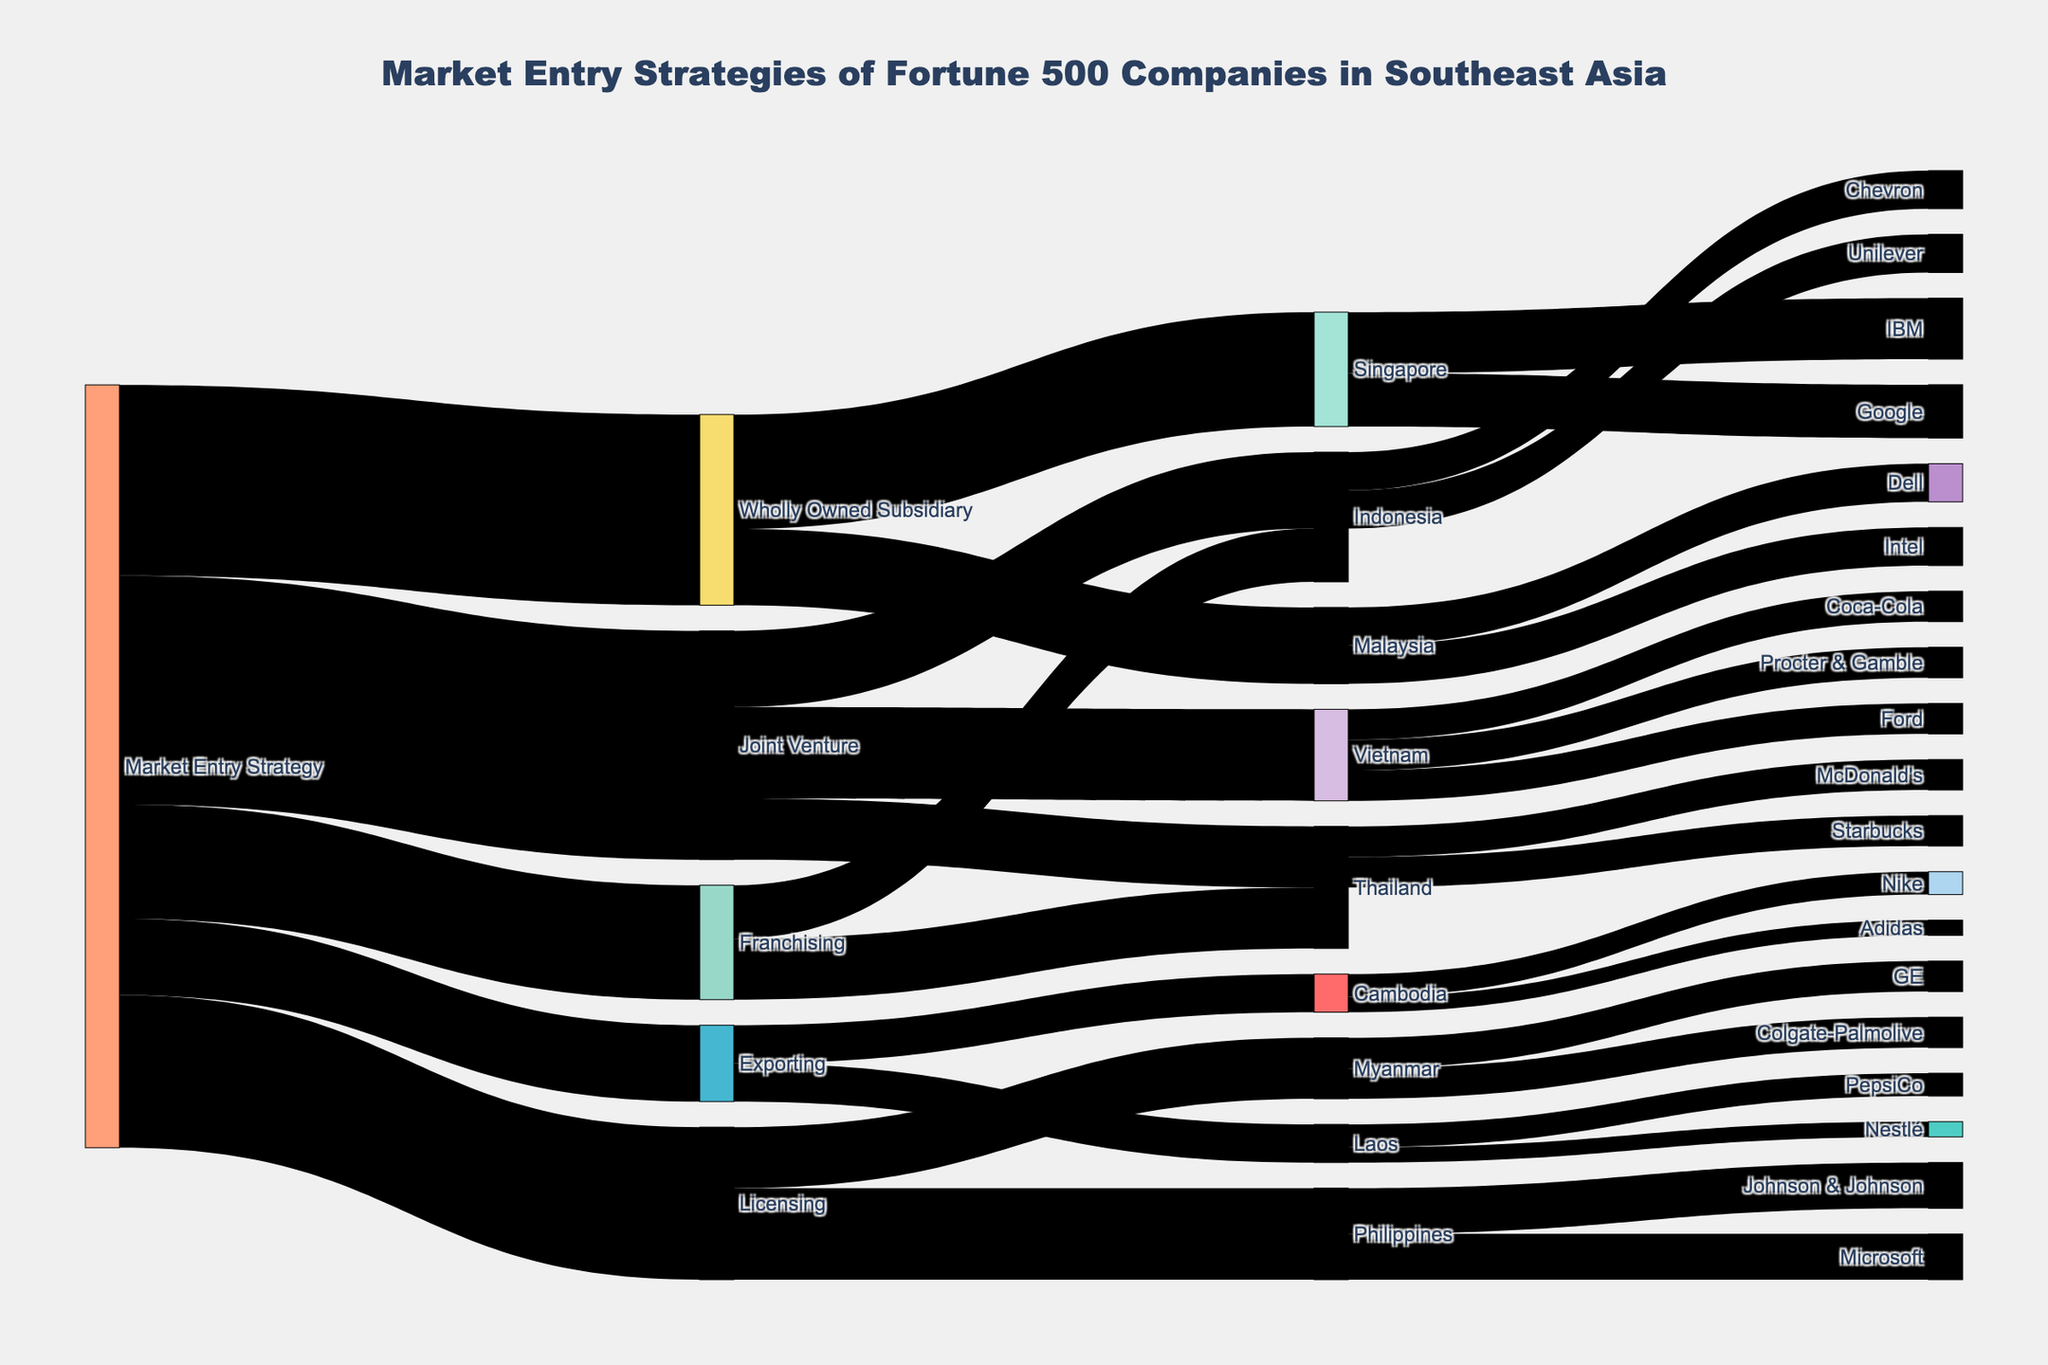What's the most popular market entry strategy among Fortune 500 companies in Southeast Asia? The Sankey diagram clearly shows that "Joint Venture" has the largest flow from "Market Entry Strategy" with a value of 30.
Answer: Joint Venture How many companies executed the Wholly Owned Subsidiary strategy in Malaysia? Follow the flow from "Wholly Owned Subsidiary" to "Malaysia"; the value is 10.
Answer: 10 Which countries are targeted by companies using the Licensing strategy? Follow the "Licensing" flow; it branches into the "Philippines" and "Myanmar".
Answer: Philippines and Myanmar Add up the number of companies that used franchising in Thailand and Indonesia. From the "Franchising" flow, the value to "Thailand" is 8 and to "Indonesia" is 7. Sum them up: 8 + 7 = 15.
Answer: 15 What is the total number of companies that entered Vietnam through a joint venture? Follow "Joint Venture" to "Vietnam," then sum up the companies: Coca-Cola (4) + Ford (4) + Procter & Gamble (4) = 12.
Answer: 12 Compare the number of companies using the Exporting strategy in Cambodia to those in Laos. Which is higher? The values for "Exporting" flow to both "Cambodia" and "Laos" are equal at 5 each.
Answer: Neither, they are equal Which company has the largest presence in Singapore through the Wholly Owned Subsidiary strategy? Follow the flow from "Wholly Owned Subsidiary" to "Singapore", then find the value for IBM (8) and Google (7). IBM has the higher value.
Answer: IBM What is the combined number of companies entering Southeast Asia through Licensing and Exporting? Summing the values of "Licensing" (20) and "Exporting" (10): 20 + 10 = 30.
Answer: 30 What is the least popular market entry strategy? Comparing the values of all strategies originating from "Market Entry Strategy," "Exporting" has the smallest value of 10.
Answer: Exporting 